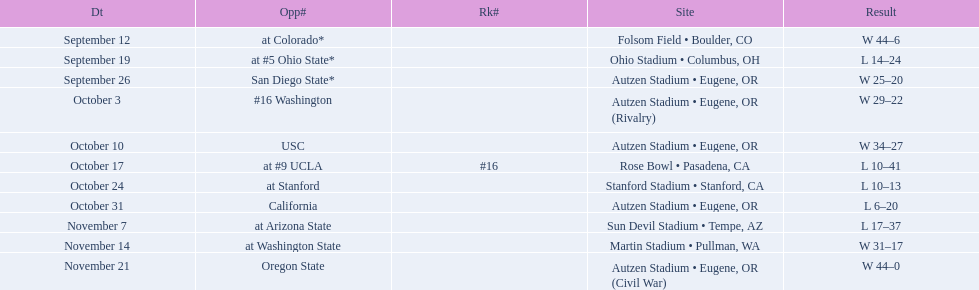What is the number of away games ? 6. 